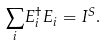<formula> <loc_0><loc_0><loc_500><loc_500>\underset { i } { \sum } E _ { i } ^ { \dagger } E _ { i } = I ^ { S } .</formula> 